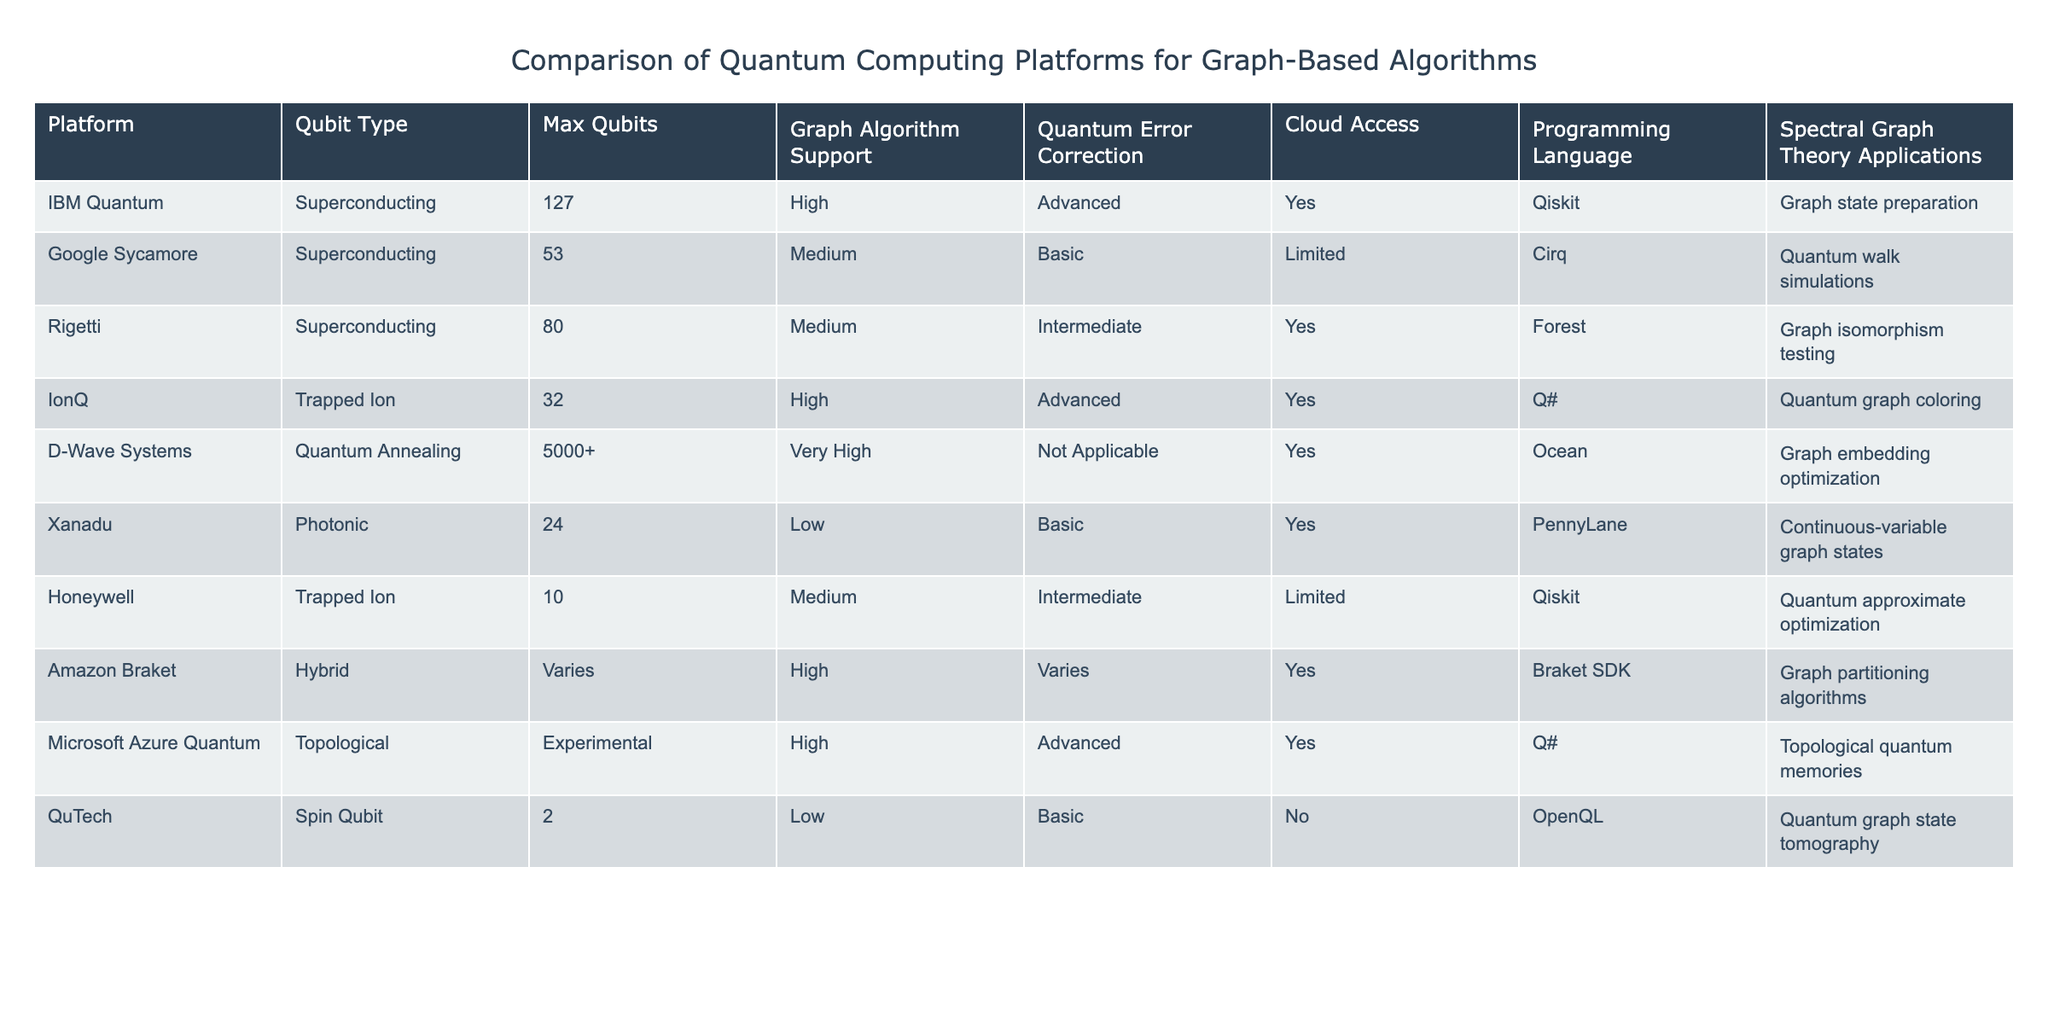What is the qubit type of the IBM Quantum platform? The IBM Quantum platform uses superconducting qubits, as indicated in the "Qubit Type" column.
Answer: Superconducting Which platforms provide advanced quantum error correction? The platforms that offer advanced quantum error correction are IBM Quantum, IonQ, and Microsoft Azure Quantum, as checked in the "Quantum Error Correction" column.
Answer: 3 platforms What is the maximum number of qubits available in D-Wave Systems? The D-Wave Systems platform lists a maximum of over 5000 qubits in the "Max Qubits" column.
Answer: 5000+ Do both trapped ion platforms have medium graph algorithm support? Checking the "Graph Algorithm Support" column, IonQ has high support while Honeywell has medium support, so they do not both have medium support.
Answer: No Which platform supports the most diverse programming languages for graph-based algorithms, and what are they? By looking at the "Programming Language" column, Amazon Braket supports the Braket SDK, while other platforms mainly use Qiskit, Cirq, and other specific languages, indicating varied support, but it isn't clear if one is more diverse; it's best to state Qiskit is the most common among others.
Answer: Qiskit is the most common language Which platform with trapped ion qubits has the capability to perform quantum graph coloring? According to the "Spectral Graph Theory Applications" column, IonQ is explicitly listed as having this capability for quantum graph coloring.
Answer: IonQ If a platform has high graph algorithm support, what could you infer about its quantum error correction capabilities? Checking the "Quantum Error Correction" for platforms with high graph algorithm support such as IBM Quantum, IonQ, and Amazon Braket, we see that two have advanced capabilities while one is variable, suggesting that high support does not guarantee advanced error correction but may indicate better overall performance.
Answer: Not guaranteed Which platforms have cloud access and support for graph embedding optimization? D-Wave Systems is the only platform that has cloud access and explicitly supports graph embedding optimization based on the "Cloud Access" and "Graph Algorithm Support" columns.
Answer: D-Wave Systems 